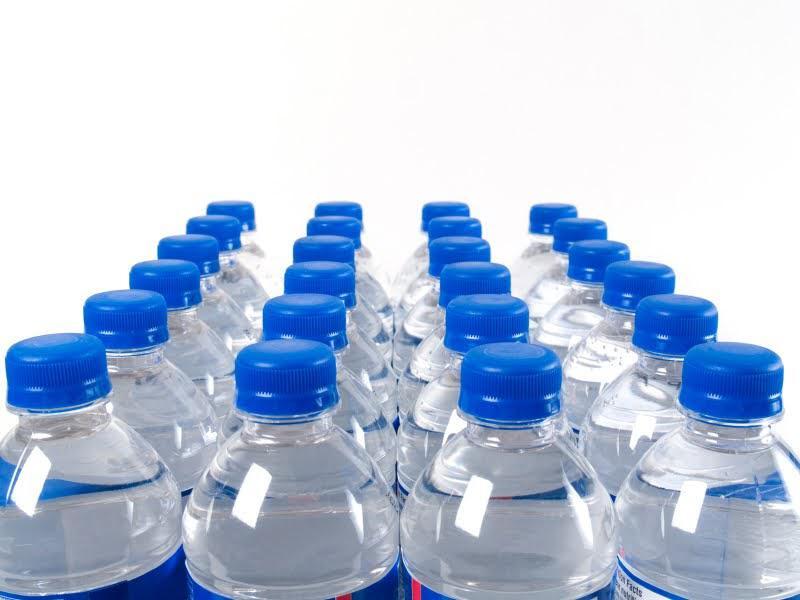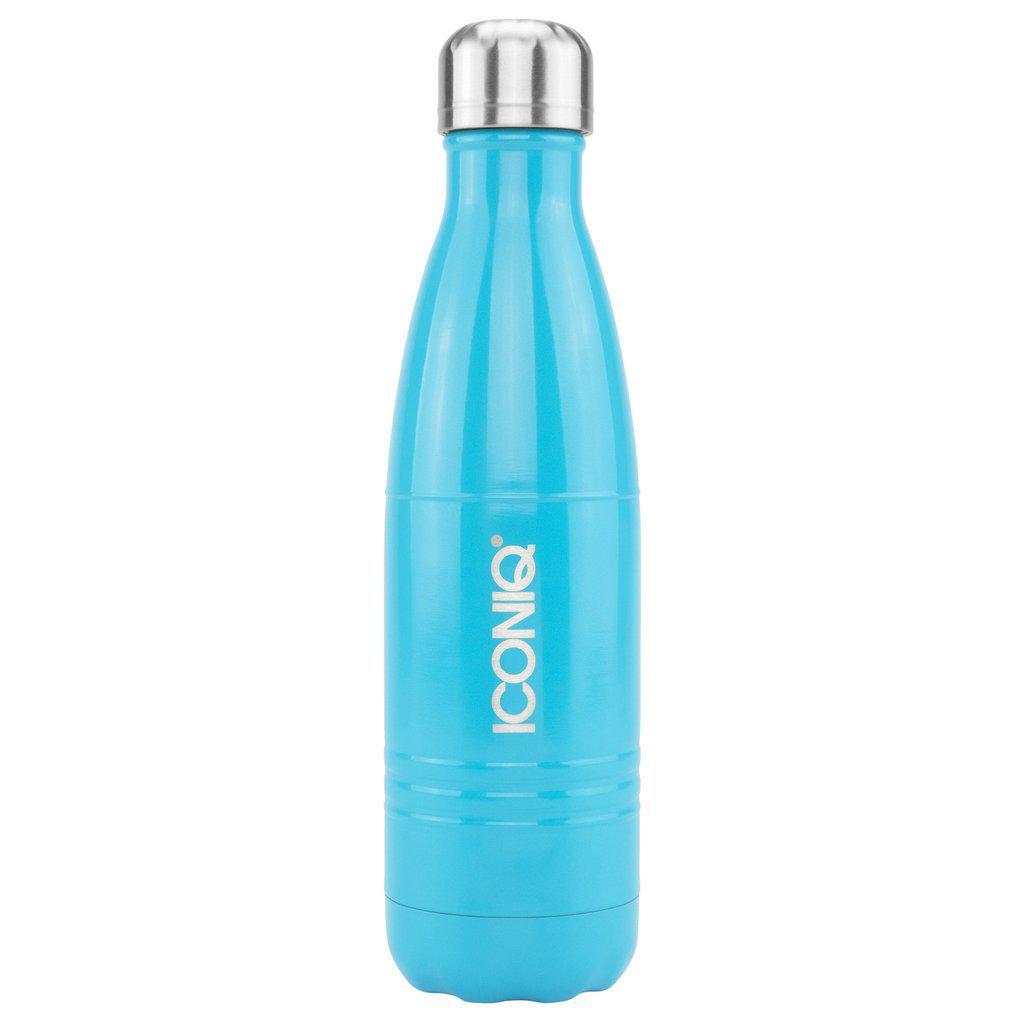The first image is the image on the left, the second image is the image on the right. Considering the images on both sides, is "An image shows one sport-type water bottle with a loop on the lid." valid? Answer yes or no. No. The first image is the image on the left, the second image is the image on the right. Analyze the images presented: Is the assertion "A clear blue water bottle has a black top with loop." valid? Answer yes or no. No. 